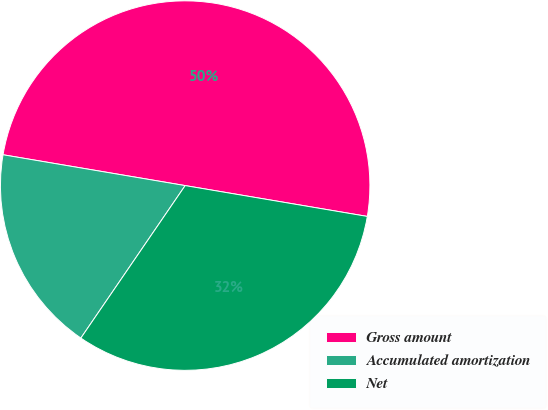<chart> <loc_0><loc_0><loc_500><loc_500><pie_chart><fcel>Gross amount<fcel>Accumulated amortization<fcel>Net<nl><fcel>50.0%<fcel>18.12%<fcel>31.88%<nl></chart> 